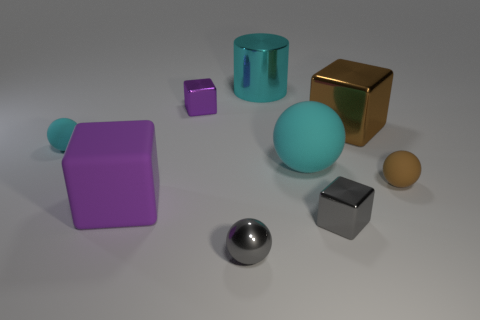Subtract 1 blocks. How many blocks are left? 3 Subtract all blocks. How many objects are left? 5 Add 3 metal blocks. How many metal blocks are left? 6 Add 2 large green rubber cylinders. How many large green rubber cylinders exist? 2 Subtract 1 gray cubes. How many objects are left? 8 Subtract all gray metal cubes. Subtract all big cyan metallic cylinders. How many objects are left? 7 